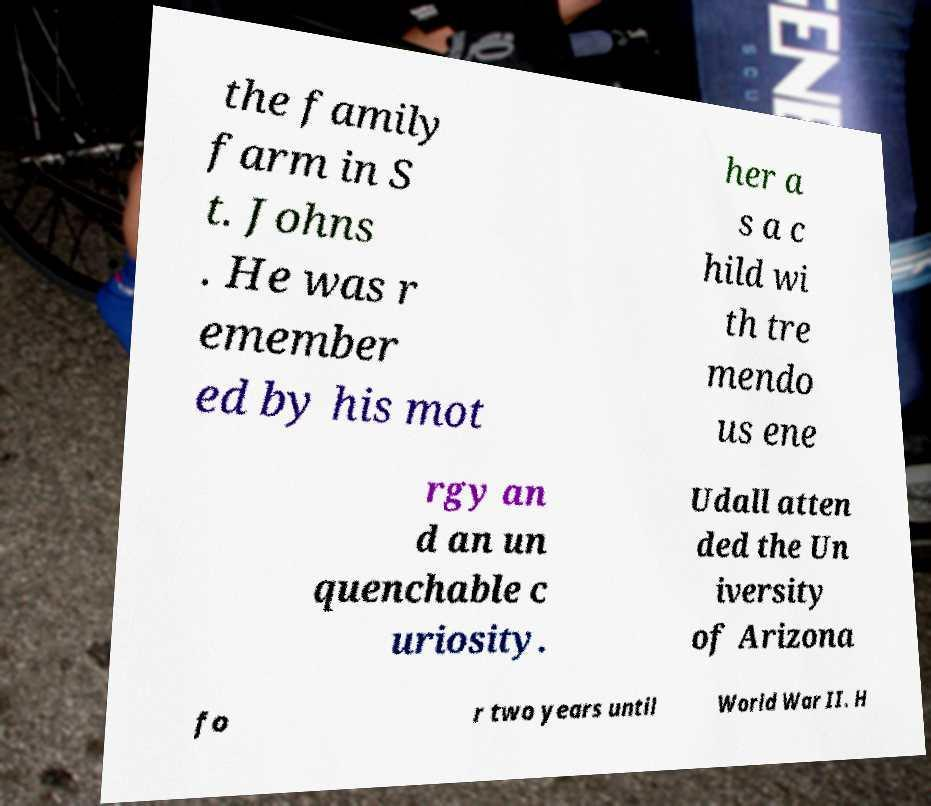Can you accurately transcribe the text from the provided image for me? the family farm in S t. Johns . He was r emember ed by his mot her a s a c hild wi th tre mendo us ene rgy an d an un quenchable c uriosity. Udall atten ded the Un iversity of Arizona fo r two years until World War II. H 